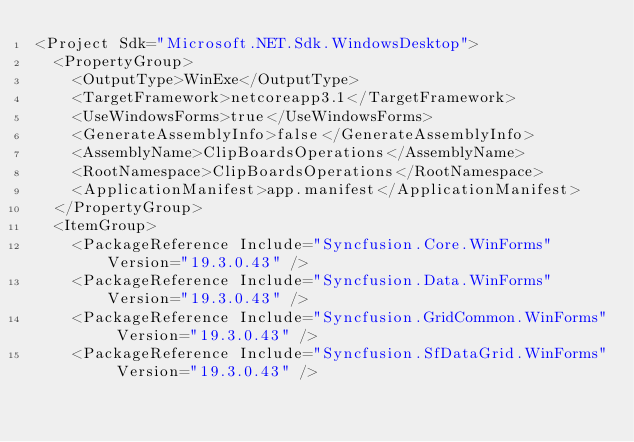Convert code to text. <code><loc_0><loc_0><loc_500><loc_500><_XML_><Project Sdk="Microsoft.NET.Sdk.WindowsDesktop">
  <PropertyGroup>
    <OutputType>WinExe</OutputType>
    <TargetFramework>netcoreapp3.1</TargetFramework>
    <UseWindowsForms>true</UseWindowsForms>
    <GenerateAssemblyInfo>false</GenerateAssemblyInfo>
    <AssemblyName>ClipBoardsOperations</AssemblyName>
    <RootNamespace>ClipBoardsOperations</RootNamespace>
    <ApplicationManifest>app.manifest</ApplicationManifest>
  </PropertyGroup>
  <ItemGroup>
    <PackageReference Include="Syncfusion.Core.WinForms" Version="19.3.0.43" />
    <PackageReference Include="Syncfusion.Data.WinForms" Version="19.3.0.43" />
    <PackageReference Include="Syncfusion.GridCommon.WinForms" Version="19.3.0.43" />
    <PackageReference Include="Syncfusion.SfDataGrid.WinForms" Version="19.3.0.43" /></code> 